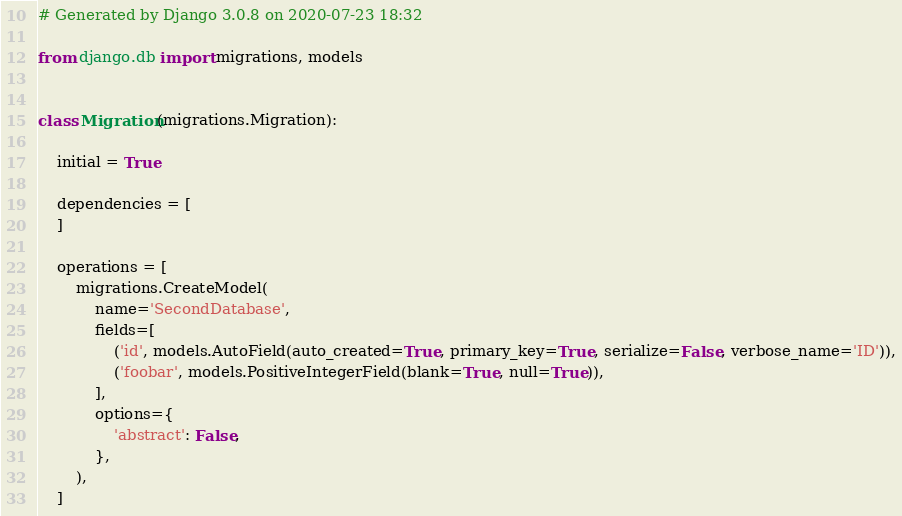Convert code to text. <code><loc_0><loc_0><loc_500><loc_500><_Python_># Generated by Django 3.0.8 on 2020-07-23 18:32

from django.db import migrations, models


class Migration(migrations.Migration):

    initial = True

    dependencies = [
    ]

    operations = [
        migrations.CreateModel(
            name='SecondDatabase',
            fields=[
                ('id', models.AutoField(auto_created=True, primary_key=True, serialize=False, verbose_name='ID')),
                ('foobar', models.PositiveIntegerField(blank=True, null=True)),
            ],
            options={
                'abstract': False,
            },
        ),
    ]
</code> 